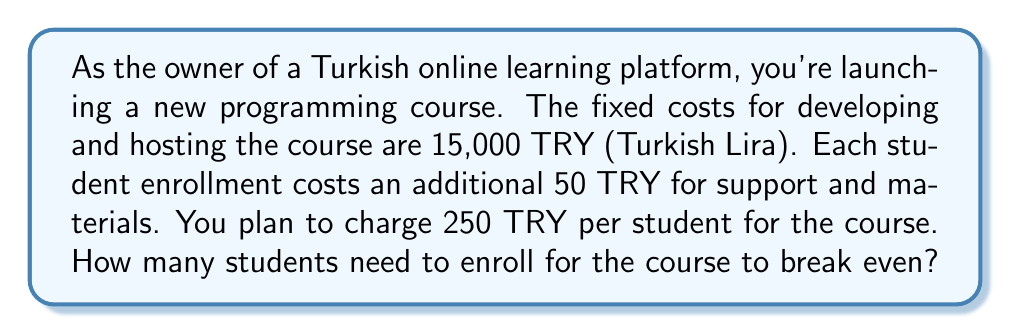Could you help me with this problem? Let's approach this step-by-step using linear equations:

1) Define variables:
   Let $x$ = number of students
   Let $y$ = total revenue/cost in TRY

2) Set up the revenue equation:
   Revenue = Price per student × Number of students
   $y = 250x$

3) Set up the cost equation:
   Total Cost = Fixed costs + (Variable cost per student × Number of students)
   $y = 15000 + 50x$

4) At the break-even point, revenue equals cost:
   $250x = 15000 + 50x$

5) Solve the equation:
   $250x - 50x = 15000$
   $200x = 15000$
   $x = 15000 / 200 = 75$

Therefore, 75 students need to enroll for the course to break even.

To verify:
Revenue at 75 students: $250 × 75 = 18750$ TRY
Cost at 75 students: $15000 + (50 × 75) = 18750$ TRY

Revenue equals cost, confirming the break-even point.
Answer: 75 students 